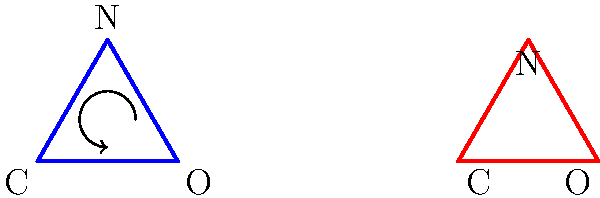Given the 2D representation of a chemical structure on the left, how many degrees of clockwise rotation are required to align it with the target structure on the right? To solve this problem, we need to follow these steps:

1. Identify the initial and target orientations of the molecule:
   - Initial: C at bottom left, O at bottom right, N at top
   - Target: C at bottom right, O at bottom left, N at top

2. Determine the rotation needed to align the structures:
   - We need to rotate the C-O bond from the left side to the right side
   - This requires a 180° rotation

3. Consider the direction of rotation:
   - The question asks for clockwise rotation
   - A 180° clockwise rotation will align the structures correctly

4. Verify the result:
   - After a 180° clockwise rotation, C will be at bottom right, O at bottom left, and N at top
   - This matches the target structure

Therefore, a 180° clockwise rotation is required to align the initial structure with the target structure.
Answer: 180° 